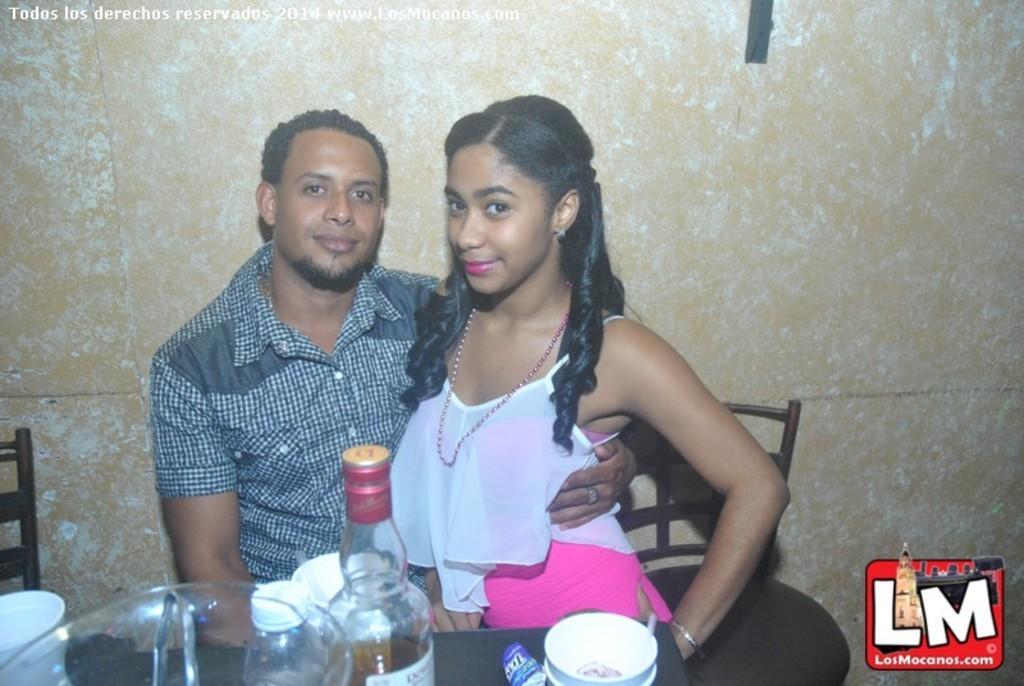Can you describe this image briefly? In this image there are 2 persons, at the right side woman is sitting on the chair taking support of the man in the center. The man in a center is holding a woman with his hand and having smile on his face, in front there is a bottle, cup which is kept on the table. In the background there is a wall. At the bottom right we can see a alphabets as L. M los mocanos. com 